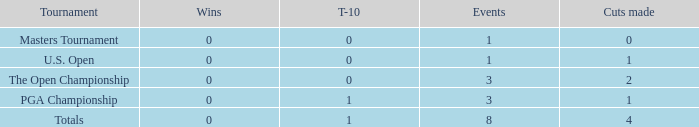For events with under 3 times played and fewer than 1 cut made, what is the total number of top-10 finishes? 1.0. 